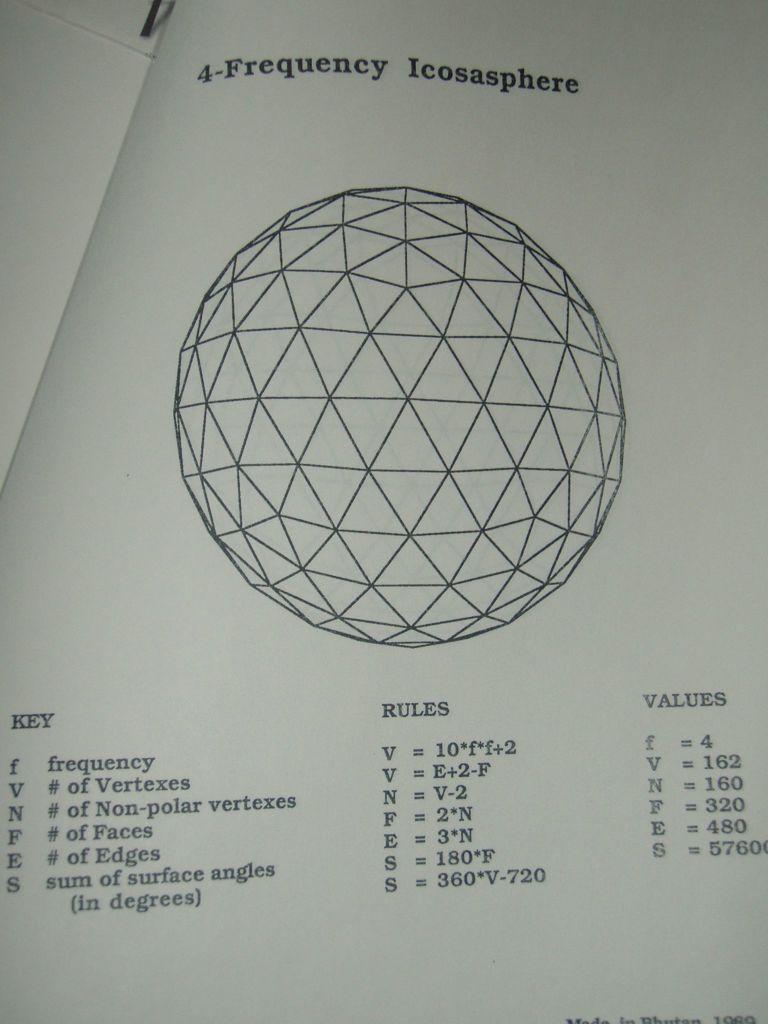How would you summarize this image in a sentence or two? In this picture we can observe a sphere on the paper. We can observe some notations, formulas and values on the paper. 